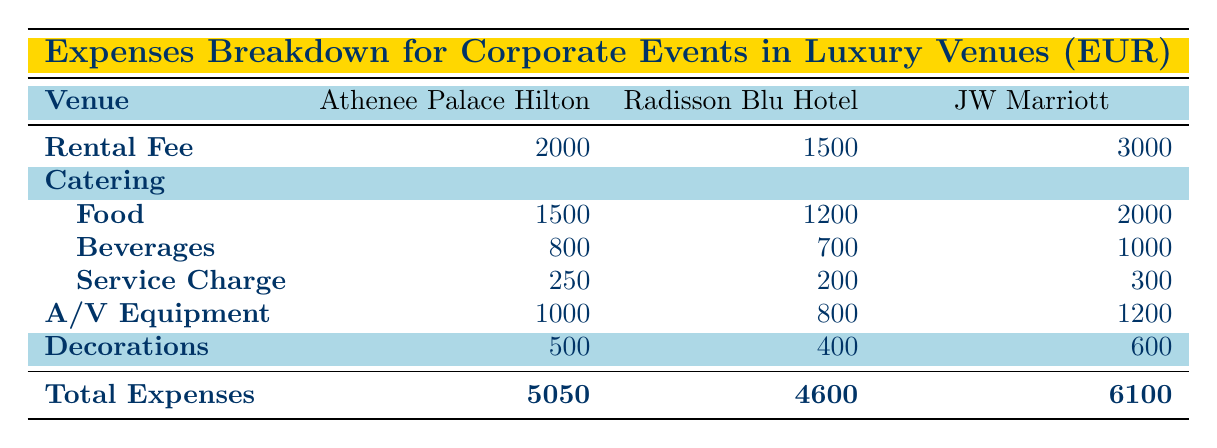What is the total expense for holding an event at the Radisson Blu Hotel? The table clearly states that the total expenses for an event at the Radisson Blu Hotel are listed at the bottom row for that venue. It shows 4600.
Answer: 4600 How much is the catering service charge at the JW Marriott Bucharest Grand Hotel? Looking under the Catering section for JW Marriott, the service charge is specifically listed as 300.
Answer: 300 Which venue has the highest total expenses? By comparing the total expenses column for all three venues, the JW Marriott Bucharest Grand Hotel shows the highest total, which is 6100.
Answer: JW Marriott Bucharest Grand Hotel What is the total catering cost for an event at the Athenee Palace Hilton, and how does it compare to the Radisson Blu Hotel? For the Athenee Palace Hilton, total catering cost is 1500 (food) + 800 (beverages) + 250 (service charge) = 2550. For Radisson Blu, it is 1200 + 700 + 200 = 2100. Therefore, Athenee Palace Hilton has a higher catering cost than Radisson Blu by 2550 - 2100 = 450.
Answer: 2550; Athenee Palace Hilton's catering is higher by 450 Did the Radisson Blu Hotel have more expenses on A/V Equipment compared to the Catering service charge? The A/V Equipment cost for Radisson Blu is 800, while the Catering service charge is 200. Since 800 is greater than 200, this statement is true.
Answer: Yes What is the average rental fee across all three venues? The rental fees for the venues are 2000 (Athenee Palace Hilton), 1500 (Radisson Blu), and 3000 (JW Marriott). The sum is 2000 + 1500 + 3000 = 6500. Dividing by the number of venues (3), the average rental fee = 6500/3 which equals approximately 2166.67.
Answer: Approximately 2166.67 How much more does one spend on decorations at the JW Marriott compared to the Radisson Blu Hotel? The decorations cost at JW Marriott is 600, and at Radisson Blu, it's 400. To find the difference, we subtract: 600 - 400 = 200. This means it costs 200 more for decorations at JW Marriott.
Answer: 200 Which venue has the lowest expenses in total? By reviewing the total expenses for each venue, it’s clear that Radisson Blu Hotel has the lowest total expenses at 4600.
Answer: Radisson Blu Hotel 